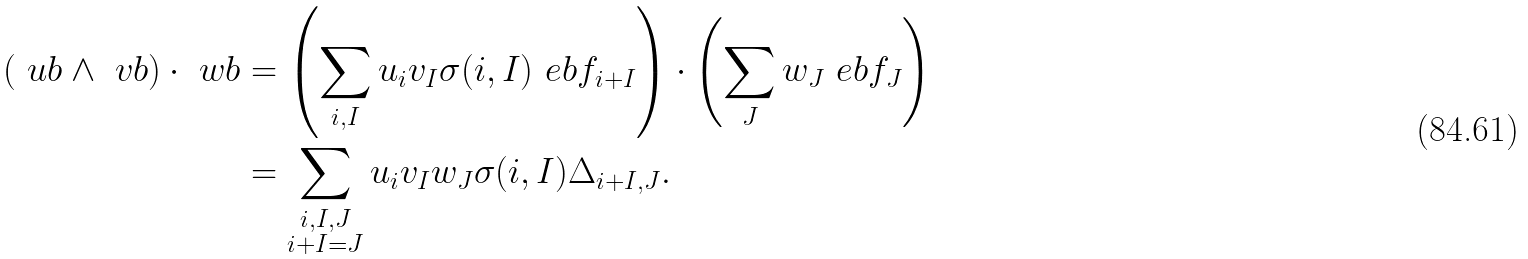Convert formula to latex. <formula><loc_0><loc_0><loc_500><loc_500>( \ u b \wedge \ v b ) \cdot \ w b & = \left ( \sum _ { i , I } u _ { i } v _ { I } \sigma ( i , I ) \ e b f _ { i + I } \right ) \cdot \left ( \sum _ { J } w _ { J } \ e b f _ { J } \right ) \\ & = \sum _ { \substack { i , I , J \\ i + I = J } } u _ { i } v _ { I } w _ { J } \sigma ( i , I ) \Delta _ { i + I , J } .</formula> 